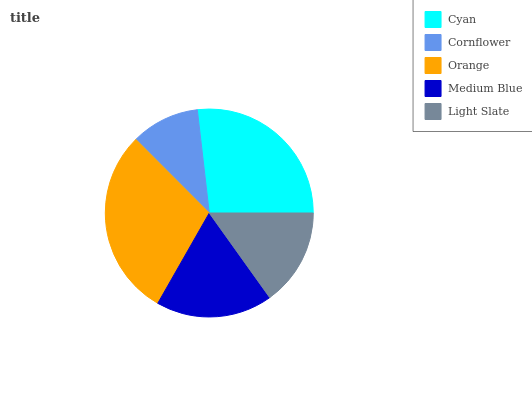Is Cornflower the minimum?
Answer yes or no. Yes. Is Orange the maximum?
Answer yes or no. Yes. Is Orange the minimum?
Answer yes or no. No. Is Cornflower the maximum?
Answer yes or no. No. Is Orange greater than Cornflower?
Answer yes or no. Yes. Is Cornflower less than Orange?
Answer yes or no. Yes. Is Cornflower greater than Orange?
Answer yes or no. No. Is Orange less than Cornflower?
Answer yes or no. No. Is Medium Blue the high median?
Answer yes or no. Yes. Is Medium Blue the low median?
Answer yes or no. Yes. Is Orange the high median?
Answer yes or no. No. Is Cyan the low median?
Answer yes or no. No. 